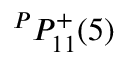<formula> <loc_0><loc_0><loc_500><loc_500>{ } ^ { P } { P } _ { 1 { 1 } } ^ { + } ( { 5 } )</formula> 